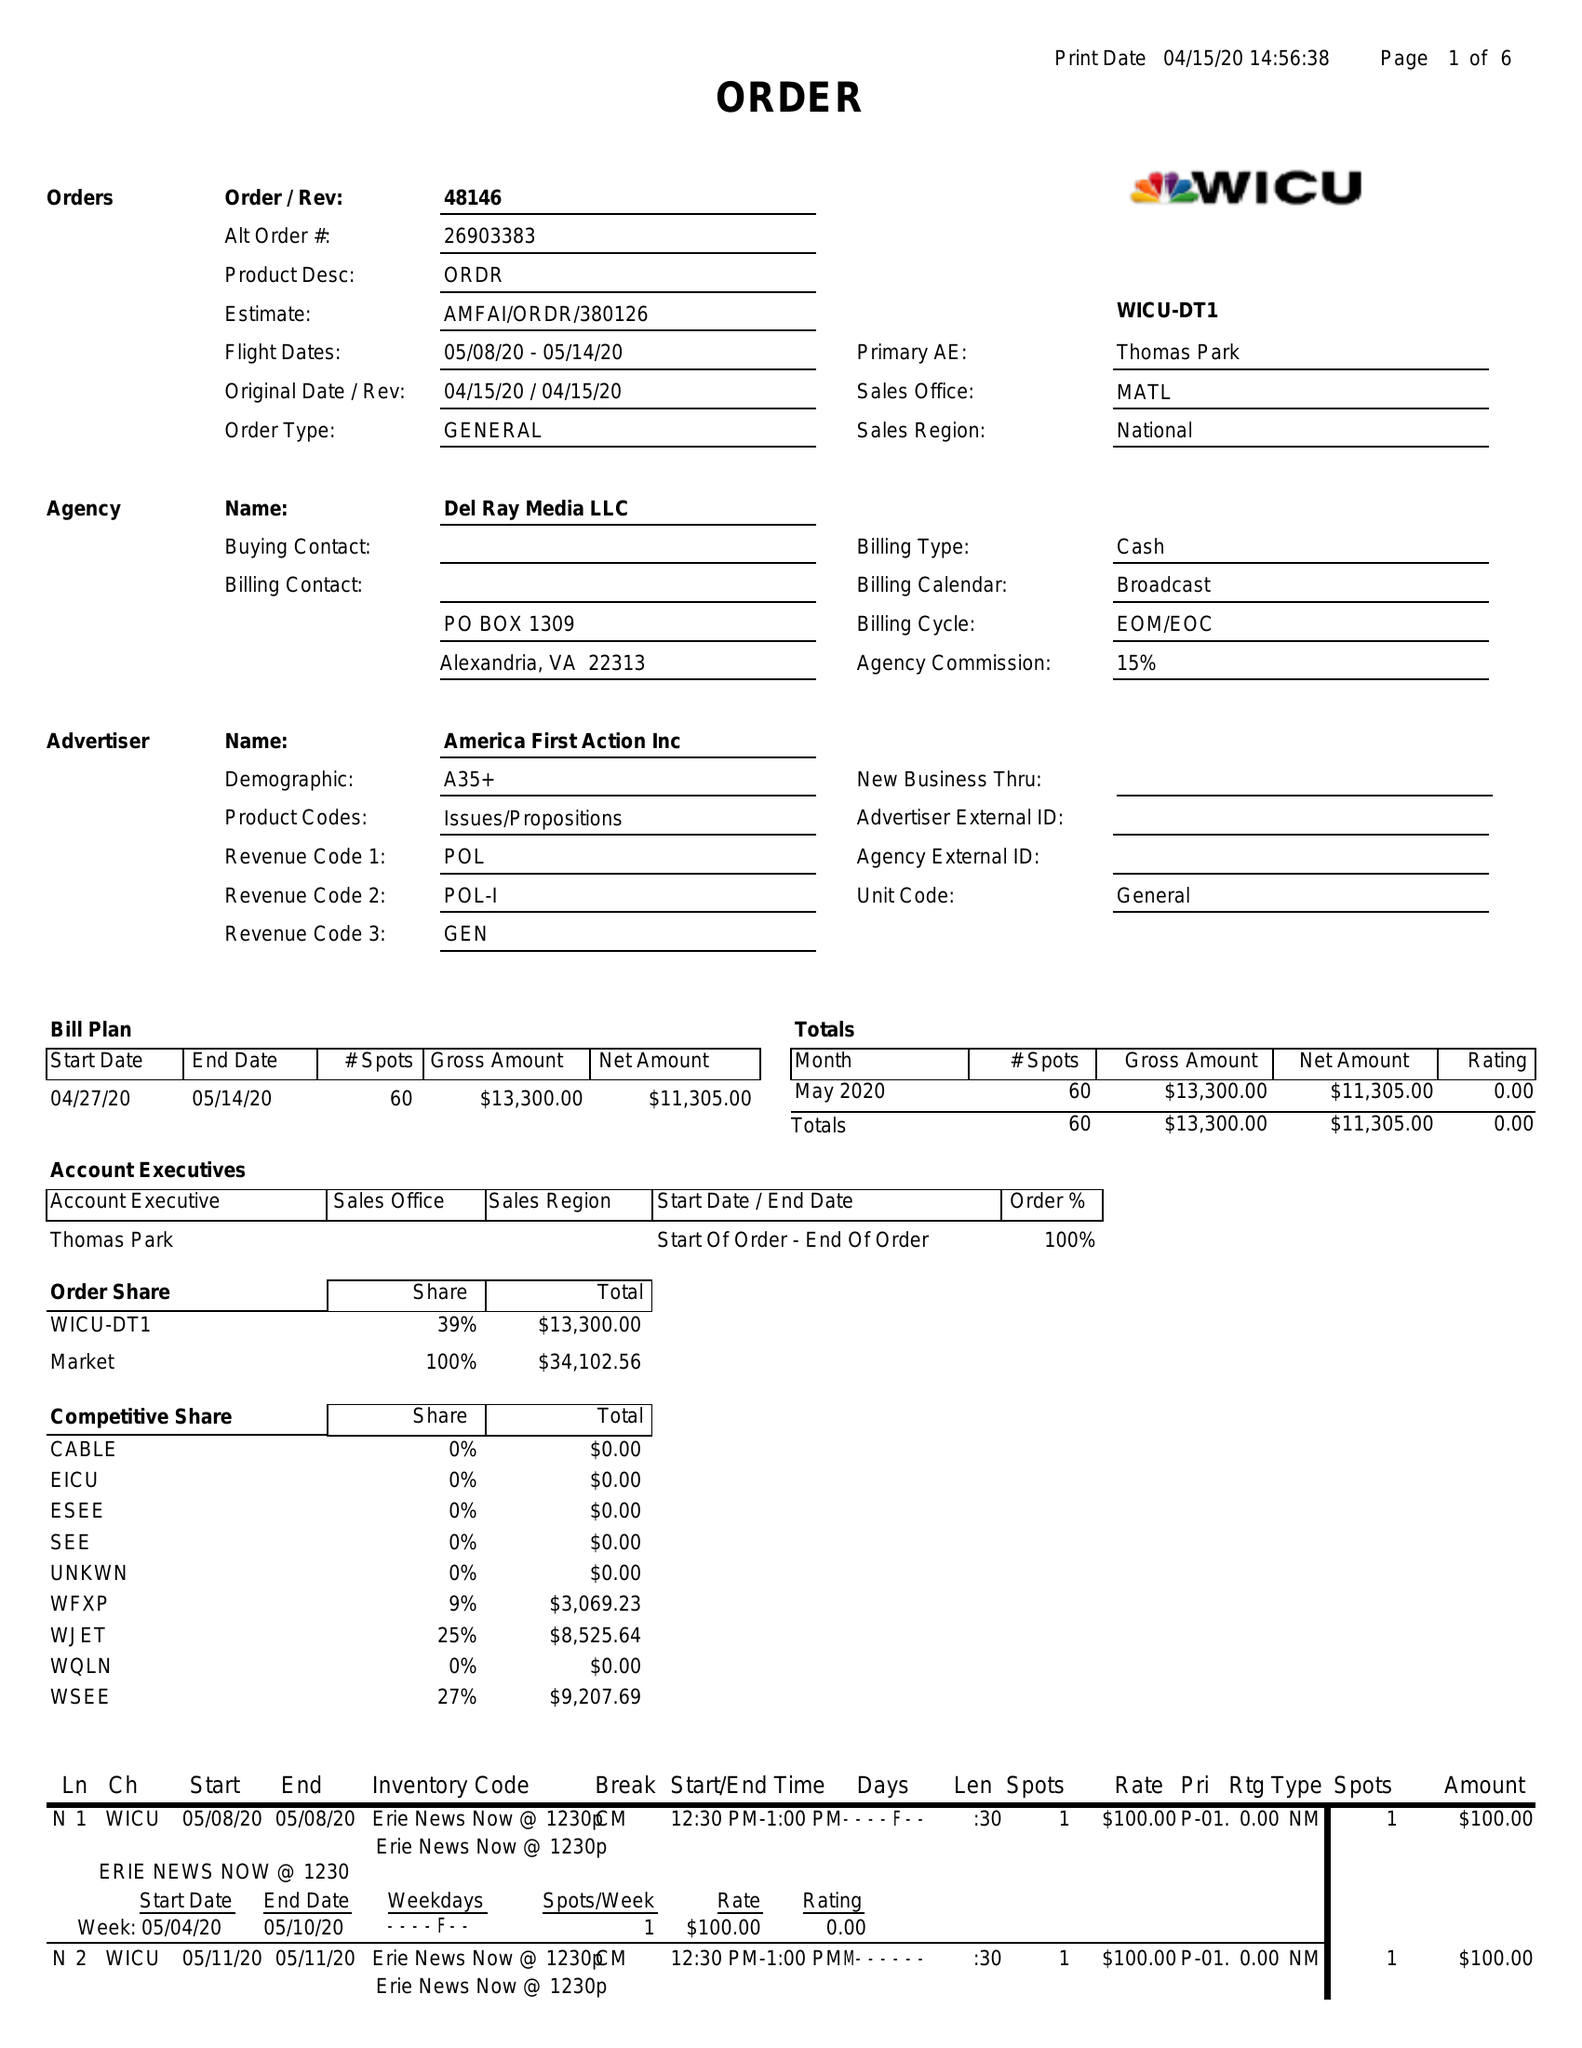What is the value for the advertiser?
Answer the question using a single word or phrase. AMERICA FIRST ACTION INC 